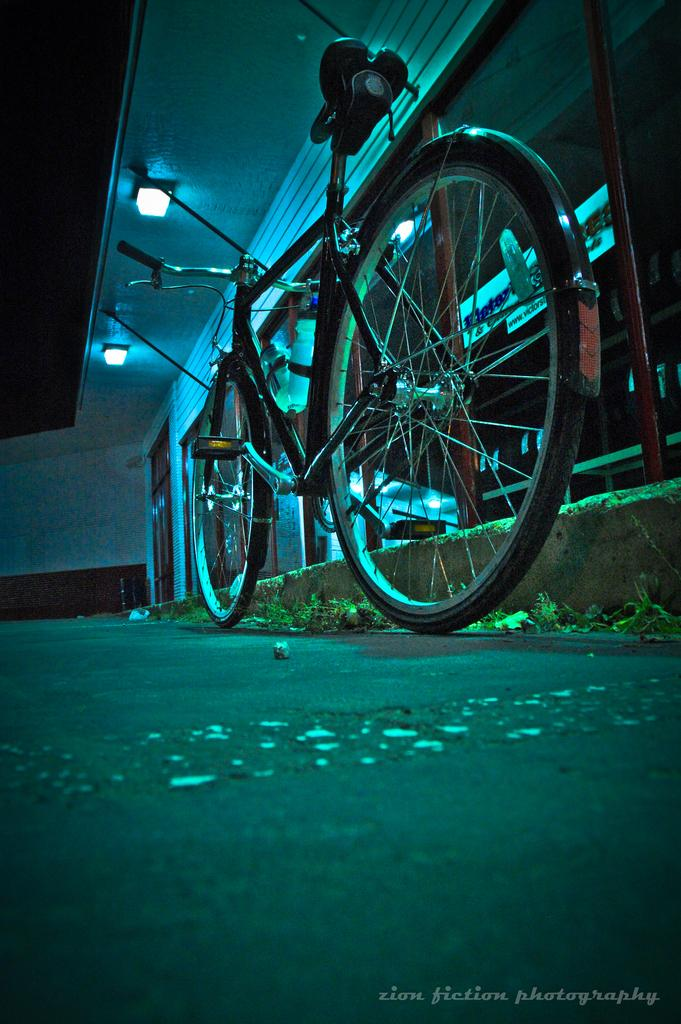What is the main subject in the center of the image? There is a cycle in the center of the image. Where is the cycle located? The cycle is on the road. What can be seen above the cycle in the image? There is a ceiling with lights in the image. What is present at the bottom of the image? There is some text at the bottom of the image. How many ladybugs can be seen on the mountain in the image? There are no ladybugs or mountains present in the image. 